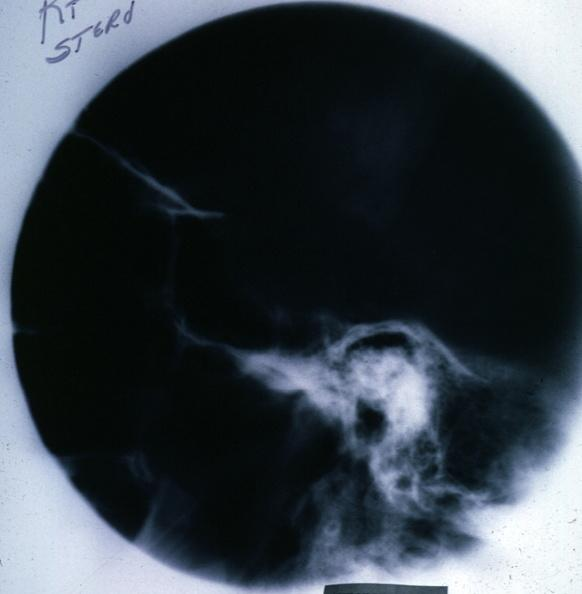where does this x-ray been taken?
Answer the question using a single word or phrase. Endocrine system 